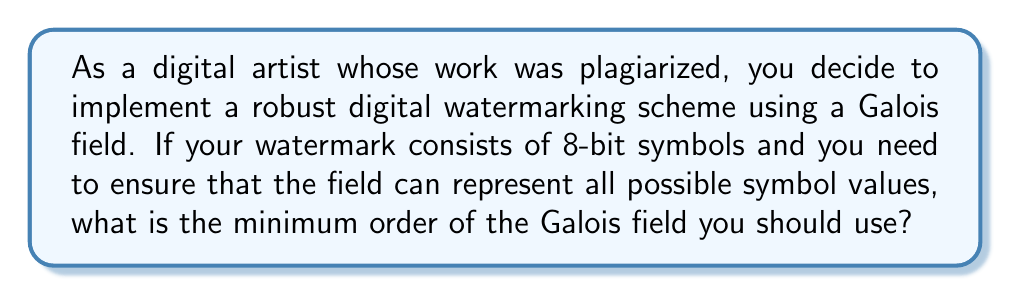What is the answer to this math problem? Let's approach this step-by-step:

1) In digital watermarking, Galois fields are often used because they provide a finite set of elements with well-defined arithmetic operations.

2) The order of a Galois field, denoted as $GF(p^m)$, is always a prime power, where $p$ is a prime number and $m$ is a positive integer.

3) In this case, we're dealing with 8-bit symbols. This means each symbol can represent $2^8 = 256$ different values.

4) To represent all possible 8-bit values, we need a field with at least 256 elements.

5) The smallest Galois field that satisfies this requirement is $GF(2^8)$, because:

   $$2^8 = 256$$

6) This field has exactly 256 elements, which is sufficient to represent all possible 8-bit symbols.

7) Any larger field (e.g., $GF(2^9)$) would also work, but would be unnecessarily complex for this application.

Therefore, the minimum order of the Galois field that should be used is 256.
Answer: $256$ 